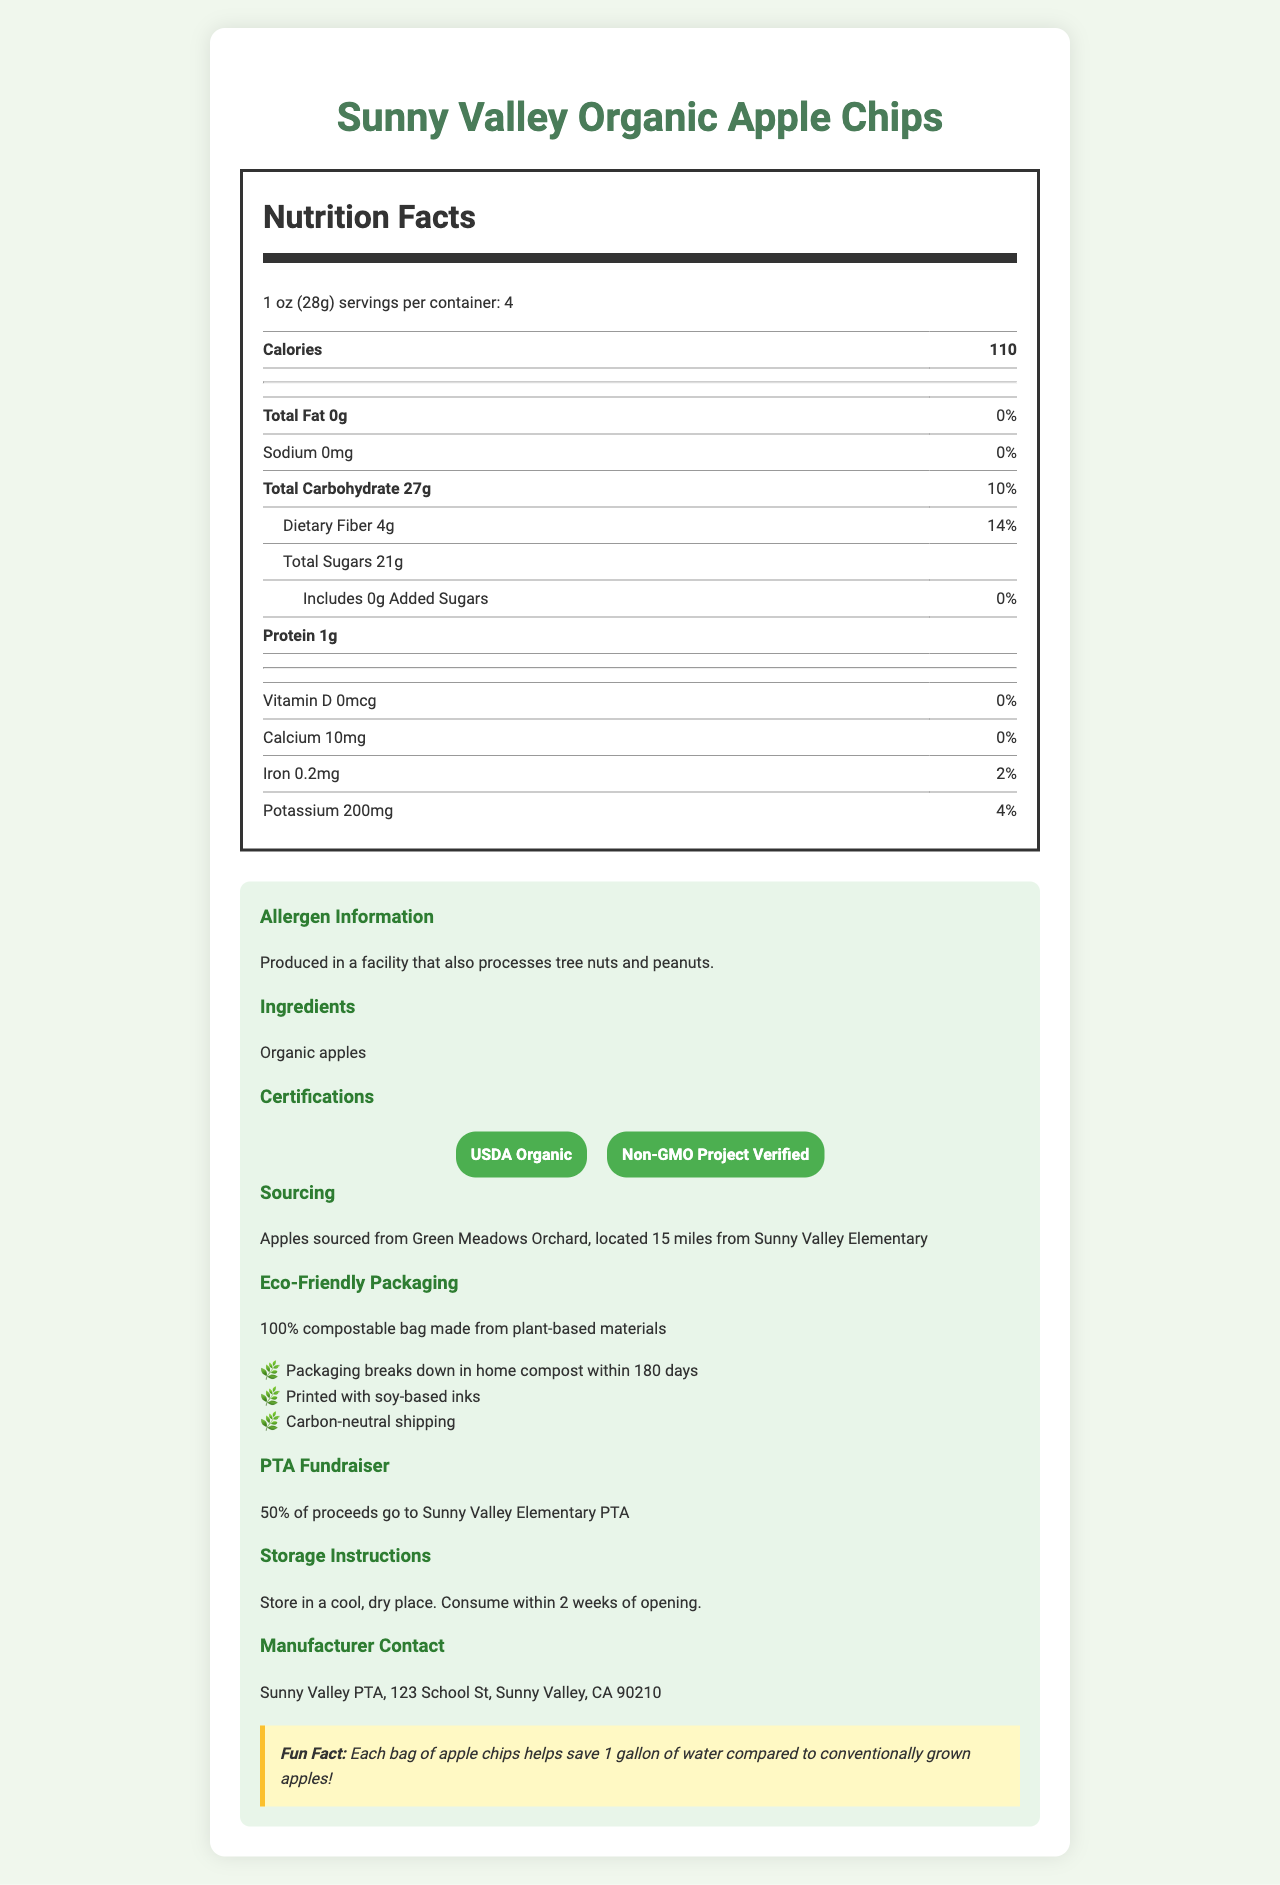what is the serving size of the Sunny Valley Organic Apple Chips? The serving size is explicitly mentioned in the Nutrition Facts Label under the serving size section.
Answer: 1 oz (28g) how many servings are there per container? This information is detailed right below the serving size on the Nutrition Facts Label.
Answer: 4 what is the total carbohydrate content per serving, and its daily value percentage? The amount of total carbohydrate per serving is listed as 27g, and its daily value percentage is 10%, both shown in the Nutrition Facts Label.
Answer: 27g, 10% are there any added sugars in the Sunny Valley Organic Apple Chips? The label specifically mentions that the product includes 0g of added sugars.
Answer: No, 0g how much dietary fiber and protein are in one serving of the snack? The dietary fiber is 4g with a daily value of 14%, and the protein content is 1g as listed in the Nutrition Facts Label.
Answer: 4g of dietary fiber and 1g of protein where are the apples sourced from? This sourcing information is found under the Sourcing section in the extra information area.
Answer: Green Meadows Orchard, located 15 miles from Sunny Valley Elementary which certifications does this product have? A. USDA Organic and Non-GMO Project Verified B. USDA Vegan and Non-GMO Project Verified C. USDA Organic and Fair Trade Certified The product's certifications listed are USDA Organic and Non-GMO Project Verified as displayed under the Certifications section.
Answer: A. USDA Organic and Non-GMO Project Verified how eco-friendly is the packaging? A. Partially recyclable B. 100% compostable C. Biodegradable but not compostable The label describes that the packaging is 100% compostable and is made from plant-based materials as detailed in the Eco-Friendly Packaging section.
Answer: B. 100% compostable are these apple chips safe for someone with a peanut allergy? The allergen information clearly states that the product is produced in a facility that also processes tree nuts and peanuts.
Answer: No true or false: the Sunny Valley Organic Apple Chips contain a significant amount of calcium. The calcium content per serving is 10mg, which has a daily value percentage of 0%, which indicates it is not significant.
Answer: False summarize the main features and benefits of the Sunny Valley Organic Apple Chips. The document provides detailed nutritional information, allergen details, certifications, eco-friendly features, sourcing information, and mentions that 50% of proceeds support the Sunny Valley Elementary PTA, making it a sustainable and community-friendly choice.
Answer: Sunny Valley Organic Apple Chips are a healthy, organic snack option with no added sugars and high dietary fiber. They are produced locally with eco-friendly packaging and support PTA fundraising efforts. what is the exact location of Green Meadows Orchard? The document states that the orchard is located 15 miles from Sunny Valley Elementary but does not provide the exact address or location.
Answer: Cannot be determined 